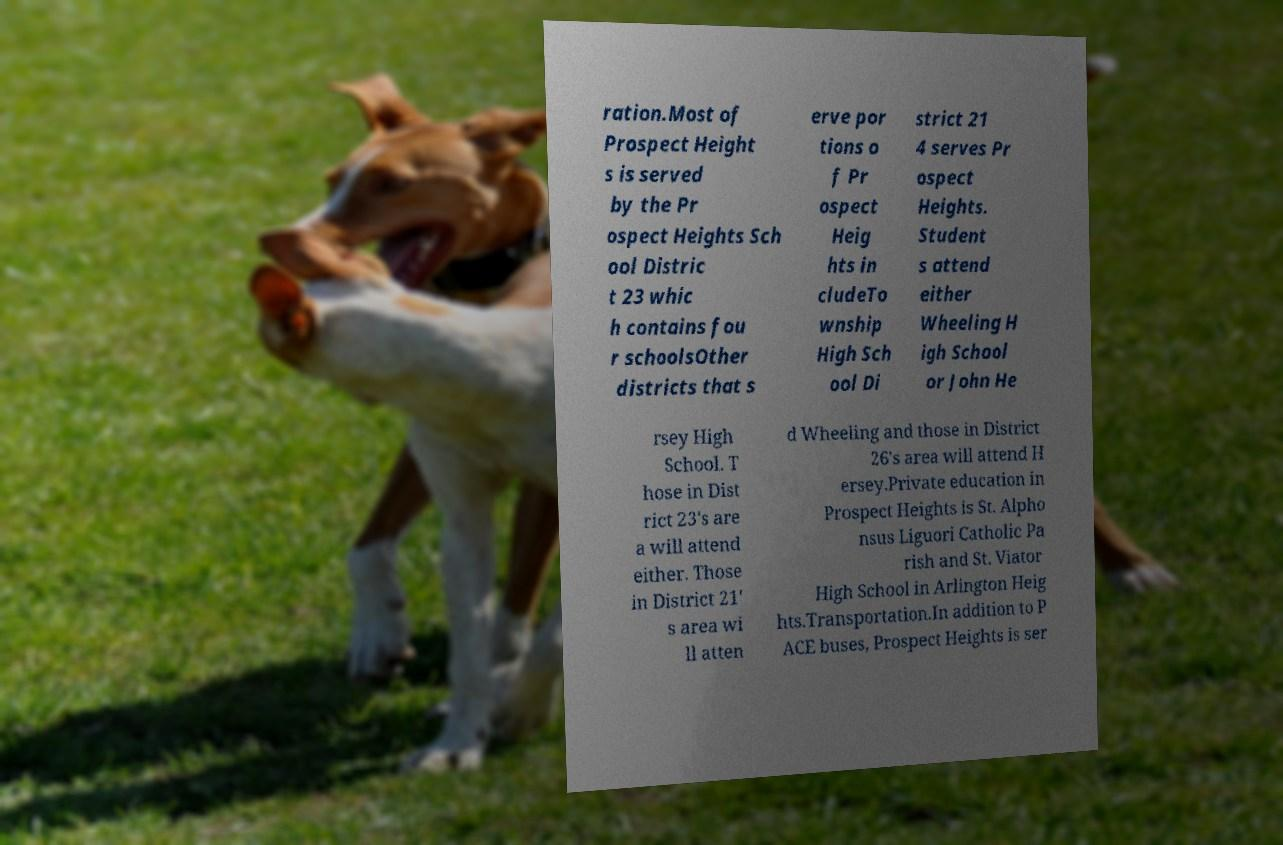What messages or text are displayed in this image? I need them in a readable, typed format. ration.Most of Prospect Height s is served by the Pr ospect Heights Sch ool Distric t 23 whic h contains fou r schoolsOther districts that s erve por tions o f Pr ospect Heig hts in cludeTo wnship High Sch ool Di strict 21 4 serves Pr ospect Heights. Student s attend either Wheeling H igh School or John He rsey High School. T hose in Dist rict 23's are a will attend either. Those in District 21' s area wi ll atten d Wheeling and those in District 26's area will attend H ersey.Private education in Prospect Heights is St. Alpho nsus Liguori Catholic Pa rish and St. Viator High School in Arlington Heig hts.Transportation.In addition to P ACE buses, Prospect Heights is ser 